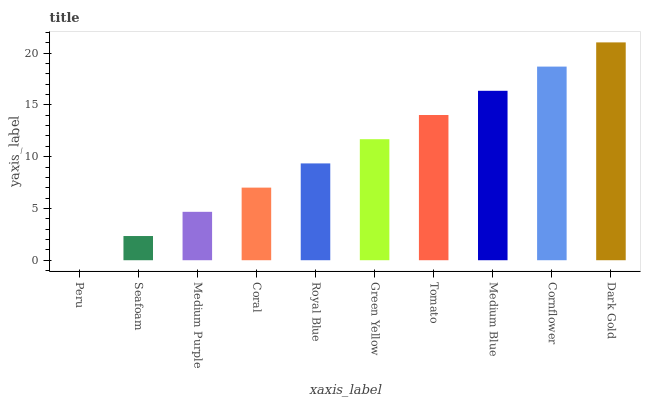Is Peru the minimum?
Answer yes or no. Yes. Is Dark Gold the maximum?
Answer yes or no. Yes. Is Seafoam the minimum?
Answer yes or no. No. Is Seafoam the maximum?
Answer yes or no. No. Is Seafoam greater than Peru?
Answer yes or no. Yes. Is Peru less than Seafoam?
Answer yes or no. Yes. Is Peru greater than Seafoam?
Answer yes or no. No. Is Seafoam less than Peru?
Answer yes or no. No. Is Green Yellow the high median?
Answer yes or no. Yes. Is Royal Blue the low median?
Answer yes or no. Yes. Is Cornflower the high median?
Answer yes or no. No. Is Medium Blue the low median?
Answer yes or no. No. 